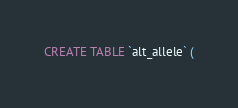Convert code to text. <code><loc_0><loc_0><loc_500><loc_500><_SQL_>CREATE TABLE `alt_allele` (</code> 